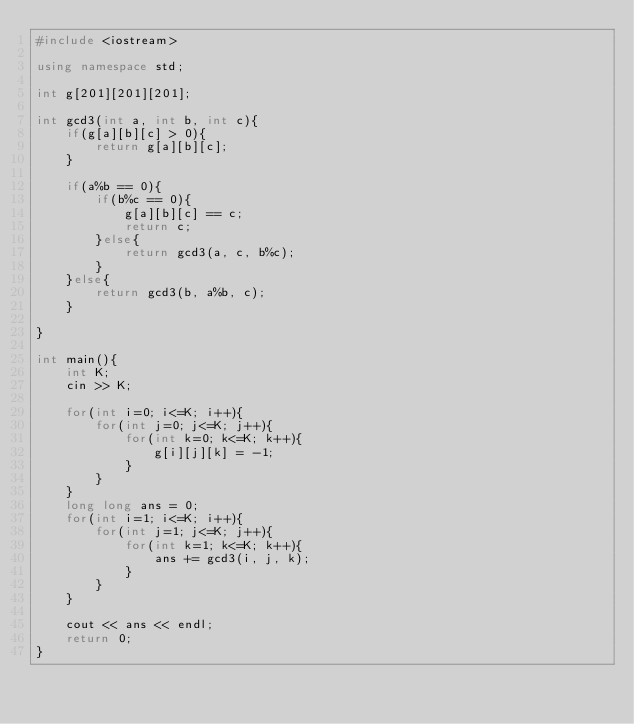Convert code to text. <code><loc_0><loc_0><loc_500><loc_500><_C++_>#include <iostream>

using namespace std;

int g[201][201][201];

int gcd3(int a, int b, int c){
    if(g[a][b][c] > 0){
        return g[a][b][c];
    }

    if(a%b == 0){
        if(b%c == 0){
            g[a][b][c] == c;
            return c;
        }else{
            return gcd3(a, c, b%c);
        }
    }else{
        return gcd3(b, a%b, c);
    }

}

int main(){
    int K;
    cin >> K;
        
    for(int i=0; i<=K; i++){
        for(int j=0; j<=K; j++){
            for(int k=0; k<=K; k++){
                g[i][j][k] = -1;
            }
        }
    }
    long long ans = 0;
    for(int i=1; i<=K; i++){
        for(int j=1; j<=K; j++){
            for(int k=1; k<=K; k++){
                ans += gcd3(i, j, k);
            }
        }
    }

    cout << ans << endl;
    return 0;
}</code> 